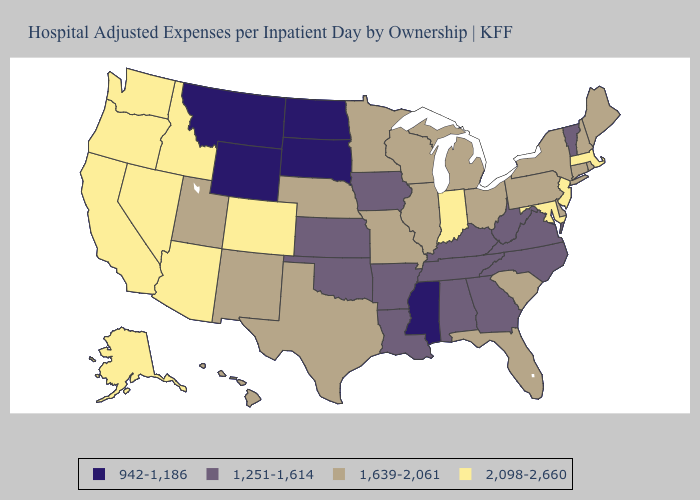Name the states that have a value in the range 1,639-2,061?
Be succinct. Connecticut, Delaware, Florida, Hawaii, Illinois, Maine, Michigan, Minnesota, Missouri, Nebraska, New Hampshire, New Mexico, New York, Ohio, Pennsylvania, Rhode Island, South Carolina, Texas, Utah, Wisconsin. Among the states that border Massachusetts , which have the highest value?
Answer briefly. Connecticut, New Hampshire, New York, Rhode Island. Does the map have missing data?
Write a very short answer. No. Does the map have missing data?
Answer briefly. No. Does Oklahoma have the highest value in the South?
Give a very brief answer. No. What is the highest value in states that border Ohio?
Answer briefly. 2,098-2,660. Name the states that have a value in the range 2,098-2,660?
Be succinct. Alaska, Arizona, California, Colorado, Idaho, Indiana, Maryland, Massachusetts, Nevada, New Jersey, Oregon, Washington. What is the lowest value in states that border Georgia?
Answer briefly. 1,251-1,614. Does Maryland have the lowest value in the South?
Answer briefly. No. Is the legend a continuous bar?
Give a very brief answer. No. Is the legend a continuous bar?
Give a very brief answer. No. Which states hav the highest value in the Northeast?
Short answer required. Massachusetts, New Jersey. Does Indiana have the highest value in the USA?
Concise answer only. Yes. Among the states that border Texas , does Arkansas have the lowest value?
Keep it brief. Yes. 